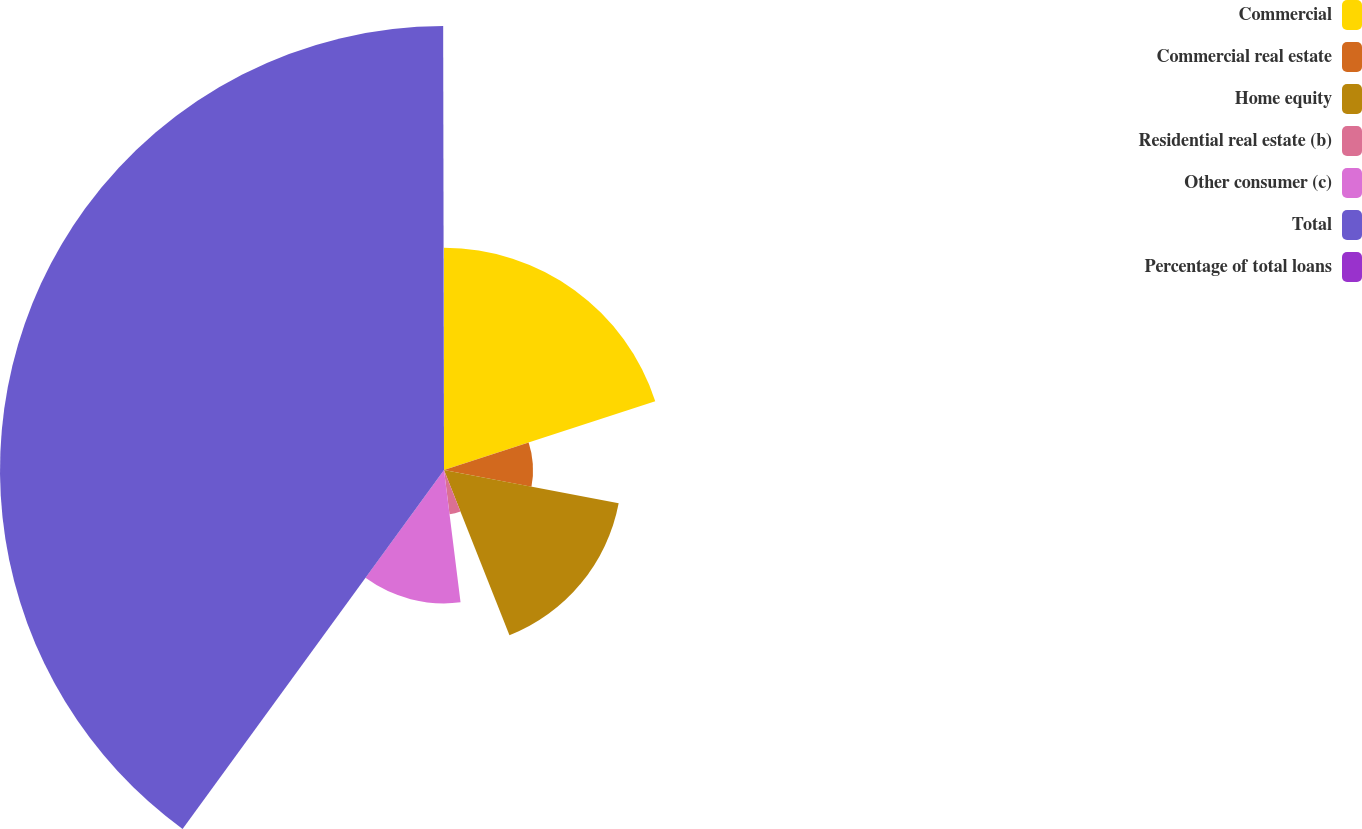Convert chart to OTSL. <chart><loc_0><loc_0><loc_500><loc_500><pie_chart><fcel>Commercial<fcel>Commercial real estate<fcel>Home equity<fcel>Residential real estate (b)<fcel>Other consumer (c)<fcel>Total<fcel>Percentage of total loans<nl><fcel>19.99%<fcel>8.01%<fcel>16.0%<fcel>4.02%<fcel>12.0%<fcel>39.95%<fcel>0.03%<nl></chart> 